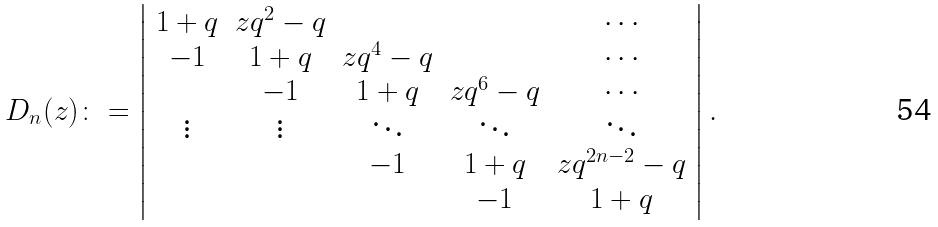Convert formula to latex. <formula><loc_0><loc_0><loc_500><loc_500>D _ { n } ( z ) \colon = \left | \begin{array} { c c c c c } 1 + q & z q ^ { 2 } - q & & & \cdots \\ - 1 & 1 + q & z q ^ { 4 } - q & & \cdots \\ & - 1 & 1 + q & z q ^ { 6 } - q & \cdots \\ \vdots & \vdots & \ddots & \ddots & \ddots \\ & & - 1 & 1 + q & z q ^ { 2 n - 2 } - q \\ & & & - 1 & 1 + q \\ \end{array} \right | .</formula> 